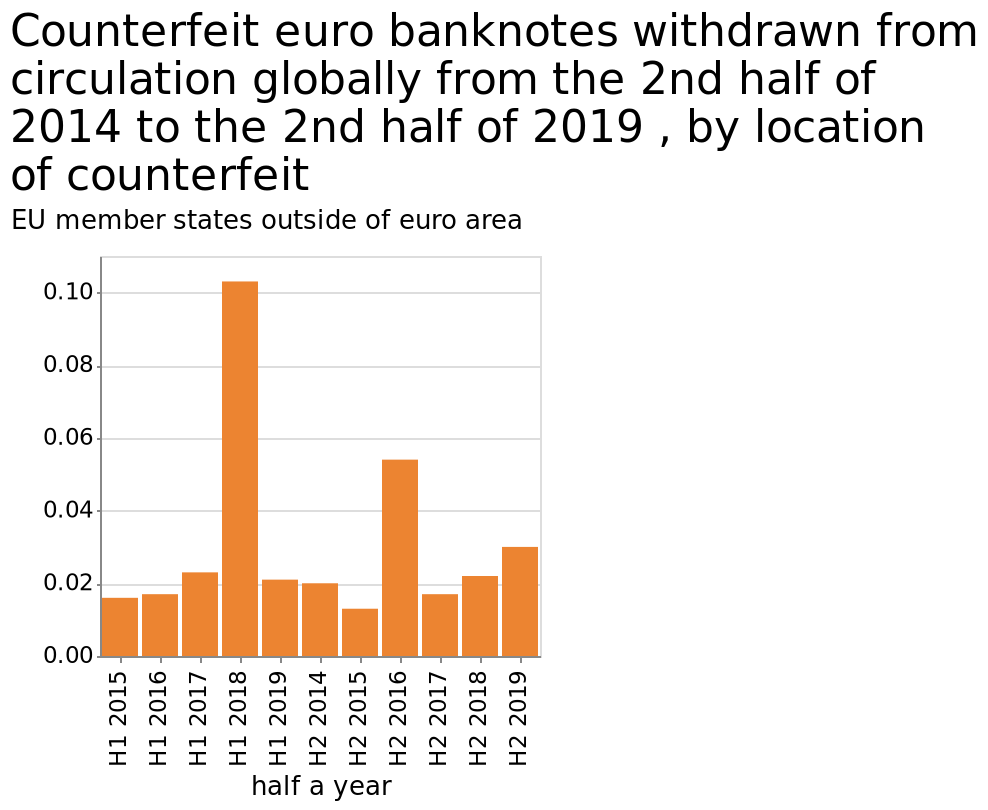<image>
What can be said about the trend of counterfeit bank notes based on the years specified? The trend of counterfeit bank notes suggests that 2018 and 2016 witnessed a significant amount of them being removed from circulation. What is the significance of 2018 and 2016 in terms of counterfeit bank notes?  2018 and 2016 were the years when the majority of counterfeit bank notes were withdrawn. 